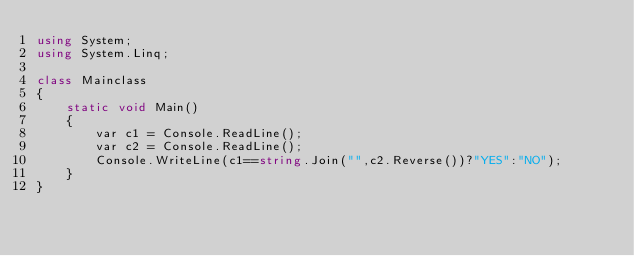Convert code to text. <code><loc_0><loc_0><loc_500><loc_500><_C#_>using System;
using System.Linq;

class Mainclass 
{
    static void Main()
    {
        var c1 = Console.ReadLine();
        var c2 = Console.ReadLine();
        Console.WriteLine(c1==string.Join("",c2.Reverse())?"YES":"NO");
    }
}</code> 